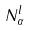<formula> <loc_0><loc_0><loc_500><loc_500>N _ { \alpha } ^ { l }</formula> 